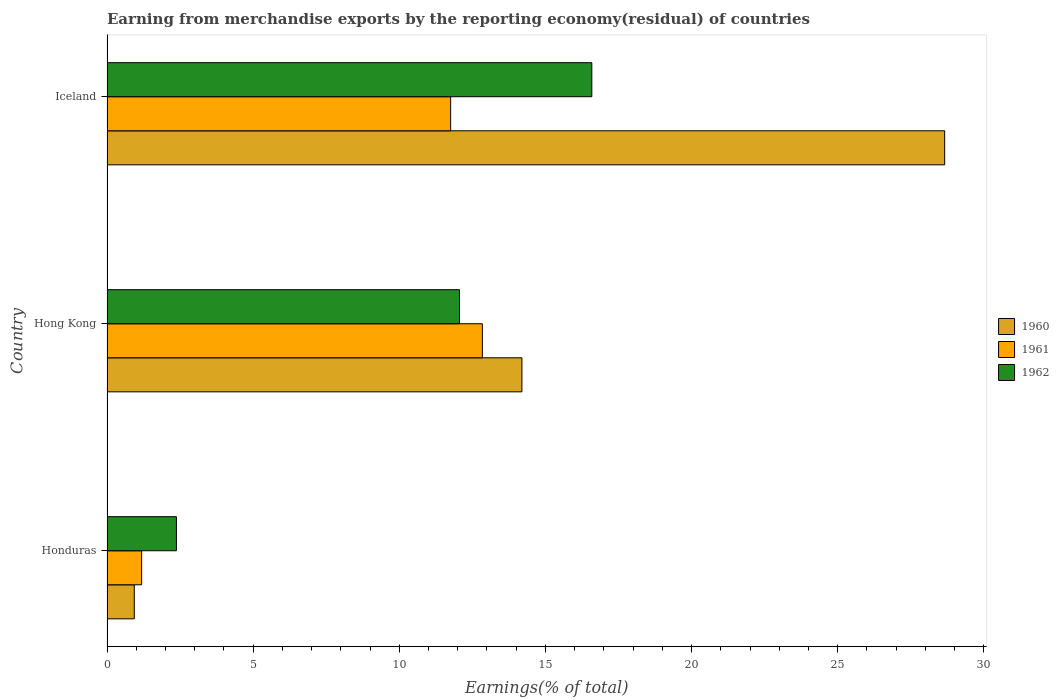How many different coloured bars are there?
Provide a short and direct response. 3. How many groups of bars are there?
Your answer should be compact. 3. Are the number of bars per tick equal to the number of legend labels?
Your answer should be very brief. Yes. Are the number of bars on each tick of the Y-axis equal?
Offer a terse response. Yes. How many bars are there on the 2nd tick from the top?
Keep it short and to the point. 3. How many bars are there on the 2nd tick from the bottom?
Make the answer very short. 3. What is the label of the 3rd group of bars from the top?
Offer a terse response. Honduras. In how many cases, is the number of bars for a given country not equal to the number of legend labels?
Keep it short and to the point. 0. What is the percentage of amount earned from merchandise exports in 1960 in Iceland?
Your response must be concise. 28.66. Across all countries, what is the maximum percentage of amount earned from merchandise exports in 1962?
Offer a terse response. 16.59. Across all countries, what is the minimum percentage of amount earned from merchandise exports in 1961?
Keep it short and to the point. 1.19. In which country was the percentage of amount earned from merchandise exports in 1961 maximum?
Keep it short and to the point. Hong Kong. In which country was the percentage of amount earned from merchandise exports in 1960 minimum?
Your answer should be very brief. Honduras. What is the total percentage of amount earned from merchandise exports in 1960 in the graph?
Provide a short and direct response. 43.79. What is the difference between the percentage of amount earned from merchandise exports in 1962 in Honduras and that in Iceland?
Provide a succinct answer. -14.21. What is the difference between the percentage of amount earned from merchandise exports in 1962 in Hong Kong and the percentage of amount earned from merchandise exports in 1960 in Iceland?
Ensure brevity in your answer.  -16.6. What is the average percentage of amount earned from merchandise exports in 1960 per country?
Provide a short and direct response. 14.6. What is the difference between the percentage of amount earned from merchandise exports in 1961 and percentage of amount earned from merchandise exports in 1962 in Honduras?
Offer a very short reply. -1.19. In how many countries, is the percentage of amount earned from merchandise exports in 1962 greater than 13 %?
Keep it short and to the point. 1. What is the ratio of the percentage of amount earned from merchandise exports in 1962 in Honduras to that in Hong Kong?
Provide a succinct answer. 0.2. Is the percentage of amount earned from merchandise exports in 1960 in Honduras less than that in Hong Kong?
Offer a very short reply. Yes. Is the difference between the percentage of amount earned from merchandise exports in 1961 in Honduras and Hong Kong greater than the difference between the percentage of amount earned from merchandise exports in 1962 in Honduras and Hong Kong?
Provide a short and direct response. No. What is the difference between the highest and the second highest percentage of amount earned from merchandise exports in 1960?
Your response must be concise. 14.46. What is the difference between the highest and the lowest percentage of amount earned from merchandise exports in 1962?
Give a very brief answer. 14.21. What does the 1st bar from the bottom in Hong Kong represents?
Provide a short and direct response. 1960. Is it the case that in every country, the sum of the percentage of amount earned from merchandise exports in 1962 and percentage of amount earned from merchandise exports in 1960 is greater than the percentage of amount earned from merchandise exports in 1961?
Provide a succinct answer. Yes. Are all the bars in the graph horizontal?
Offer a very short reply. Yes. What is the difference between two consecutive major ticks on the X-axis?
Provide a short and direct response. 5. Are the values on the major ticks of X-axis written in scientific E-notation?
Your response must be concise. No. Does the graph contain any zero values?
Provide a short and direct response. No. How many legend labels are there?
Your answer should be very brief. 3. What is the title of the graph?
Provide a succinct answer. Earning from merchandise exports by the reporting economy(residual) of countries. What is the label or title of the X-axis?
Keep it short and to the point. Earnings(% of total). What is the label or title of the Y-axis?
Your answer should be compact. Country. What is the Earnings(% of total) of 1960 in Honduras?
Keep it short and to the point. 0.93. What is the Earnings(% of total) of 1961 in Honduras?
Your answer should be compact. 1.19. What is the Earnings(% of total) in 1962 in Honduras?
Keep it short and to the point. 2.38. What is the Earnings(% of total) of 1960 in Hong Kong?
Provide a succinct answer. 14.2. What is the Earnings(% of total) of 1961 in Hong Kong?
Your answer should be compact. 12.84. What is the Earnings(% of total) of 1962 in Hong Kong?
Keep it short and to the point. 12.06. What is the Earnings(% of total) in 1960 in Iceland?
Provide a short and direct response. 28.66. What is the Earnings(% of total) of 1961 in Iceland?
Keep it short and to the point. 11.76. What is the Earnings(% of total) of 1962 in Iceland?
Give a very brief answer. 16.59. Across all countries, what is the maximum Earnings(% of total) in 1960?
Offer a terse response. 28.66. Across all countries, what is the maximum Earnings(% of total) in 1961?
Ensure brevity in your answer.  12.84. Across all countries, what is the maximum Earnings(% of total) in 1962?
Ensure brevity in your answer.  16.59. Across all countries, what is the minimum Earnings(% of total) of 1960?
Keep it short and to the point. 0.93. Across all countries, what is the minimum Earnings(% of total) of 1961?
Offer a very short reply. 1.19. Across all countries, what is the minimum Earnings(% of total) of 1962?
Ensure brevity in your answer.  2.38. What is the total Earnings(% of total) of 1960 in the graph?
Offer a terse response. 43.79. What is the total Earnings(% of total) in 1961 in the graph?
Your answer should be compact. 25.78. What is the total Earnings(% of total) in 1962 in the graph?
Provide a short and direct response. 31.02. What is the difference between the Earnings(% of total) in 1960 in Honduras and that in Hong Kong?
Offer a terse response. -13.26. What is the difference between the Earnings(% of total) of 1961 in Honduras and that in Hong Kong?
Give a very brief answer. -11.66. What is the difference between the Earnings(% of total) in 1962 in Honduras and that in Hong Kong?
Your answer should be compact. -9.69. What is the difference between the Earnings(% of total) in 1960 in Honduras and that in Iceland?
Offer a terse response. -27.73. What is the difference between the Earnings(% of total) in 1961 in Honduras and that in Iceland?
Offer a terse response. -10.57. What is the difference between the Earnings(% of total) in 1962 in Honduras and that in Iceland?
Offer a very short reply. -14.21. What is the difference between the Earnings(% of total) of 1960 in Hong Kong and that in Iceland?
Make the answer very short. -14.46. What is the difference between the Earnings(% of total) in 1961 in Hong Kong and that in Iceland?
Your answer should be very brief. 1.09. What is the difference between the Earnings(% of total) of 1962 in Hong Kong and that in Iceland?
Ensure brevity in your answer.  -4.53. What is the difference between the Earnings(% of total) in 1960 in Honduras and the Earnings(% of total) in 1961 in Hong Kong?
Make the answer very short. -11.91. What is the difference between the Earnings(% of total) of 1960 in Honduras and the Earnings(% of total) of 1962 in Hong Kong?
Make the answer very short. -11.13. What is the difference between the Earnings(% of total) in 1961 in Honduras and the Earnings(% of total) in 1962 in Hong Kong?
Make the answer very short. -10.88. What is the difference between the Earnings(% of total) of 1960 in Honduras and the Earnings(% of total) of 1961 in Iceland?
Your response must be concise. -10.82. What is the difference between the Earnings(% of total) in 1960 in Honduras and the Earnings(% of total) in 1962 in Iceland?
Offer a very short reply. -15.65. What is the difference between the Earnings(% of total) of 1961 in Honduras and the Earnings(% of total) of 1962 in Iceland?
Offer a terse response. -15.4. What is the difference between the Earnings(% of total) of 1960 in Hong Kong and the Earnings(% of total) of 1961 in Iceland?
Make the answer very short. 2.44. What is the difference between the Earnings(% of total) in 1960 in Hong Kong and the Earnings(% of total) in 1962 in Iceland?
Provide a short and direct response. -2.39. What is the difference between the Earnings(% of total) of 1961 in Hong Kong and the Earnings(% of total) of 1962 in Iceland?
Provide a succinct answer. -3.75. What is the average Earnings(% of total) of 1960 per country?
Your answer should be very brief. 14.6. What is the average Earnings(% of total) of 1961 per country?
Offer a very short reply. 8.59. What is the average Earnings(% of total) in 1962 per country?
Provide a short and direct response. 10.34. What is the difference between the Earnings(% of total) of 1960 and Earnings(% of total) of 1961 in Honduras?
Make the answer very short. -0.25. What is the difference between the Earnings(% of total) of 1960 and Earnings(% of total) of 1962 in Honduras?
Your answer should be compact. -1.44. What is the difference between the Earnings(% of total) in 1961 and Earnings(% of total) in 1962 in Honduras?
Provide a short and direct response. -1.19. What is the difference between the Earnings(% of total) of 1960 and Earnings(% of total) of 1961 in Hong Kong?
Provide a succinct answer. 1.35. What is the difference between the Earnings(% of total) in 1960 and Earnings(% of total) in 1962 in Hong Kong?
Ensure brevity in your answer.  2.13. What is the difference between the Earnings(% of total) in 1961 and Earnings(% of total) in 1962 in Hong Kong?
Offer a terse response. 0.78. What is the difference between the Earnings(% of total) of 1960 and Earnings(% of total) of 1961 in Iceland?
Your response must be concise. 16.9. What is the difference between the Earnings(% of total) of 1960 and Earnings(% of total) of 1962 in Iceland?
Ensure brevity in your answer.  12.07. What is the difference between the Earnings(% of total) of 1961 and Earnings(% of total) of 1962 in Iceland?
Provide a short and direct response. -4.83. What is the ratio of the Earnings(% of total) in 1960 in Honduras to that in Hong Kong?
Your answer should be very brief. 0.07. What is the ratio of the Earnings(% of total) of 1961 in Honduras to that in Hong Kong?
Ensure brevity in your answer.  0.09. What is the ratio of the Earnings(% of total) in 1962 in Honduras to that in Hong Kong?
Keep it short and to the point. 0.2. What is the ratio of the Earnings(% of total) in 1960 in Honduras to that in Iceland?
Make the answer very short. 0.03. What is the ratio of the Earnings(% of total) in 1961 in Honduras to that in Iceland?
Give a very brief answer. 0.1. What is the ratio of the Earnings(% of total) in 1962 in Honduras to that in Iceland?
Make the answer very short. 0.14. What is the ratio of the Earnings(% of total) of 1960 in Hong Kong to that in Iceland?
Offer a terse response. 0.5. What is the ratio of the Earnings(% of total) of 1961 in Hong Kong to that in Iceland?
Make the answer very short. 1.09. What is the ratio of the Earnings(% of total) in 1962 in Hong Kong to that in Iceland?
Your answer should be compact. 0.73. What is the difference between the highest and the second highest Earnings(% of total) in 1960?
Provide a short and direct response. 14.46. What is the difference between the highest and the second highest Earnings(% of total) of 1961?
Offer a terse response. 1.09. What is the difference between the highest and the second highest Earnings(% of total) in 1962?
Your answer should be very brief. 4.53. What is the difference between the highest and the lowest Earnings(% of total) in 1960?
Your answer should be very brief. 27.73. What is the difference between the highest and the lowest Earnings(% of total) in 1961?
Your response must be concise. 11.66. What is the difference between the highest and the lowest Earnings(% of total) of 1962?
Give a very brief answer. 14.21. 